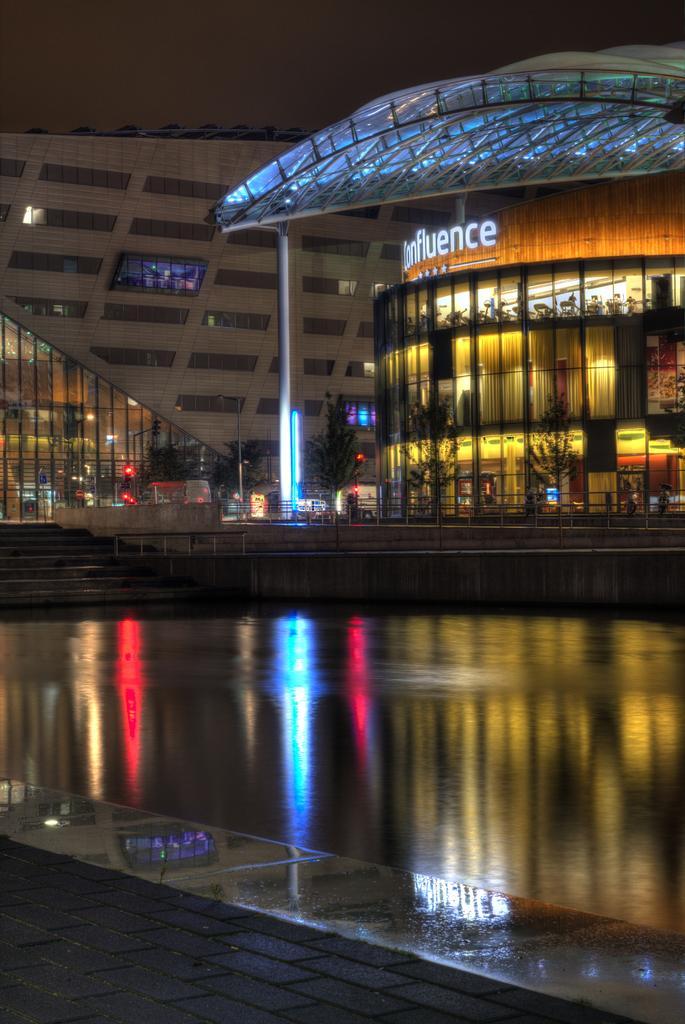How would you summarize this image in a sentence or two? In this picture there are buildings, trees, poles and lights in the background area of the image, there are stairs in the center of the image, it seems to be the picture is captured during night time. 